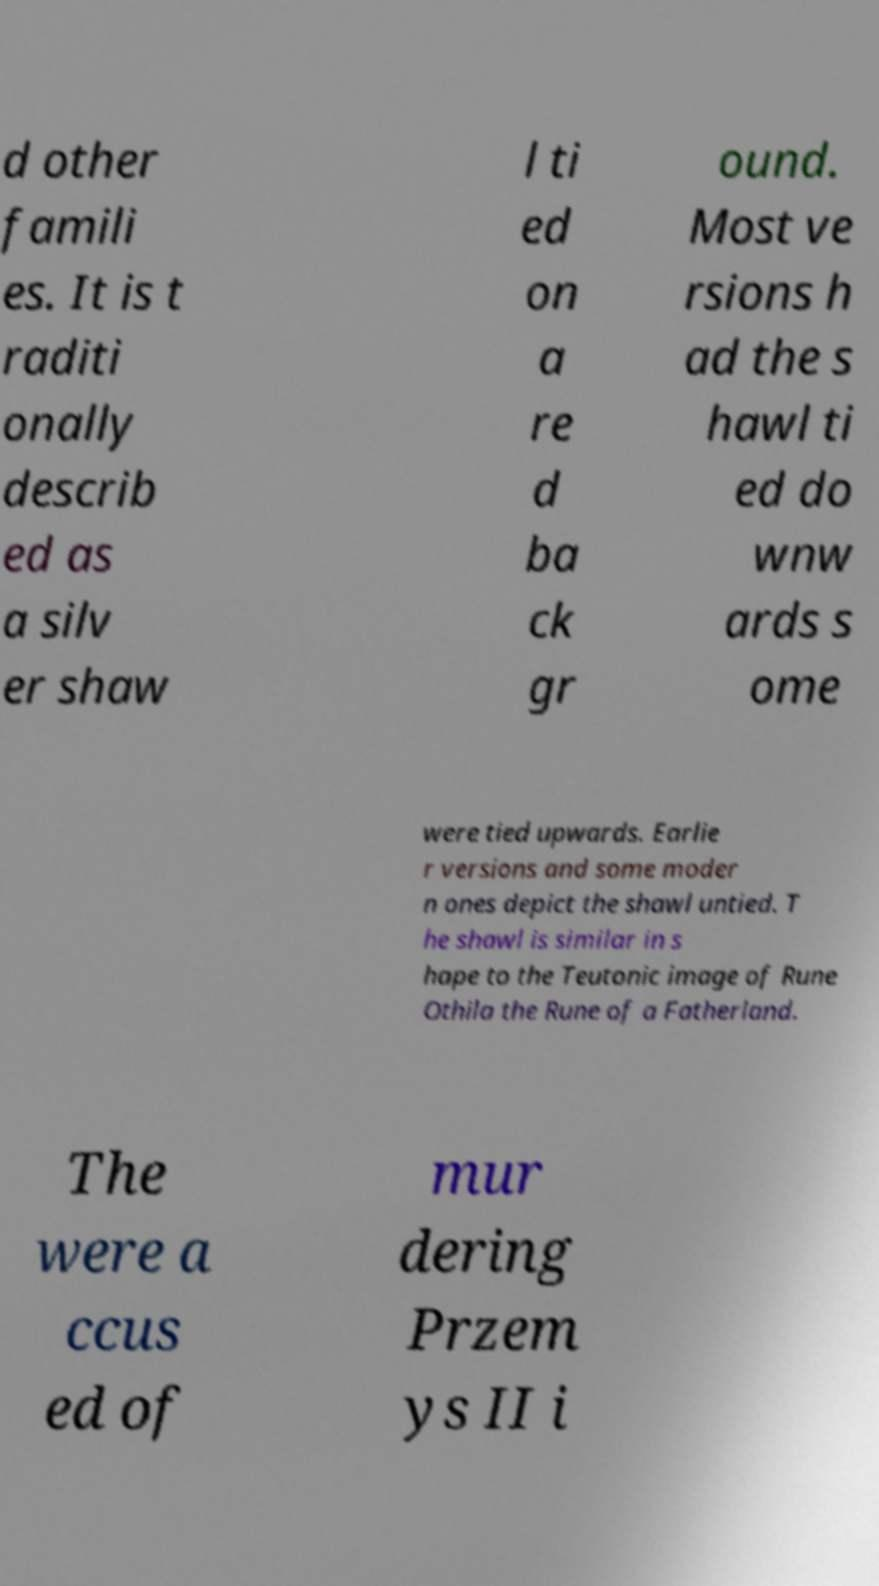Can you accurately transcribe the text from the provided image for me? d other famili es. It is t raditi onally describ ed as a silv er shaw l ti ed on a re d ba ck gr ound. Most ve rsions h ad the s hawl ti ed do wnw ards s ome were tied upwards. Earlie r versions and some moder n ones depict the shawl untied. T he shawl is similar in s hape to the Teutonic image of Rune Othila the Rune of a Fatherland. The were a ccus ed of mur dering Przem ys II i 